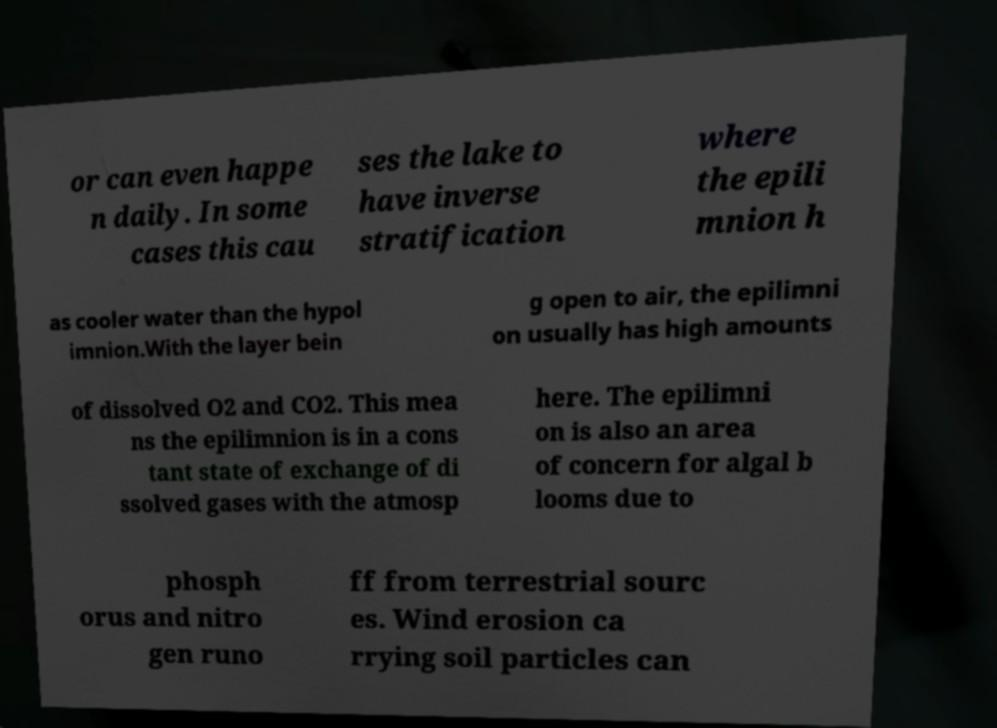For documentation purposes, I need the text within this image transcribed. Could you provide that? or can even happe n daily. In some cases this cau ses the lake to have inverse stratification where the epili mnion h as cooler water than the hypol imnion.With the layer bein g open to air, the epilimni on usually has high amounts of dissolved O2 and CO2. This mea ns the epilimnion is in a cons tant state of exchange of di ssolved gases with the atmosp here. The epilimni on is also an area of concern for algal b looms due to phosph orus and nitro gen runo ff from terrestrial sourc es. Wind erosion ca rrying soil particles can 